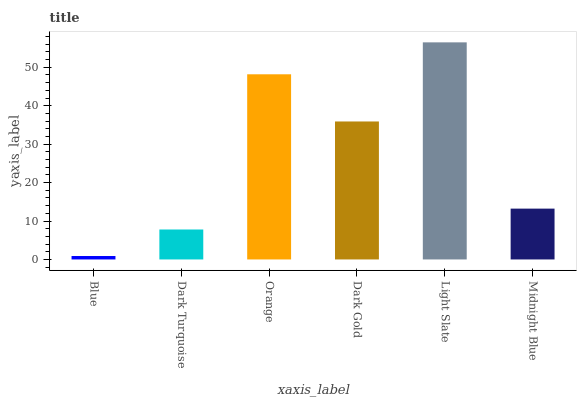Is Blue the minimum?
Answer yes or no. Yes. Is Light Slate the maximum?
Answer yes or no. Yes. Is Dark Turquoise the minimum?
Answer yes or no. No. Is Dark Turquoise the maximum?
Answer yes or no. No. Is Dark Turquoise greater than Blue?
Answer yes or no. Yes. Is Blue less than Dark Turquoise?
Answer yes or no. Yes. Is Blue greater than Dark Turquoise?
Answer yes or no. No. Is Dark Turquoise less than Blue?
Answer yes or no. No. Is Dark Gold the high median?
Answer yes or no. Yes. Is Midnight Blue the low median?
Answer yes or no. Yes. Is Orange the high median?
Answer yes or no. No. Is Orange the low median?
Answer yes or no. No. 